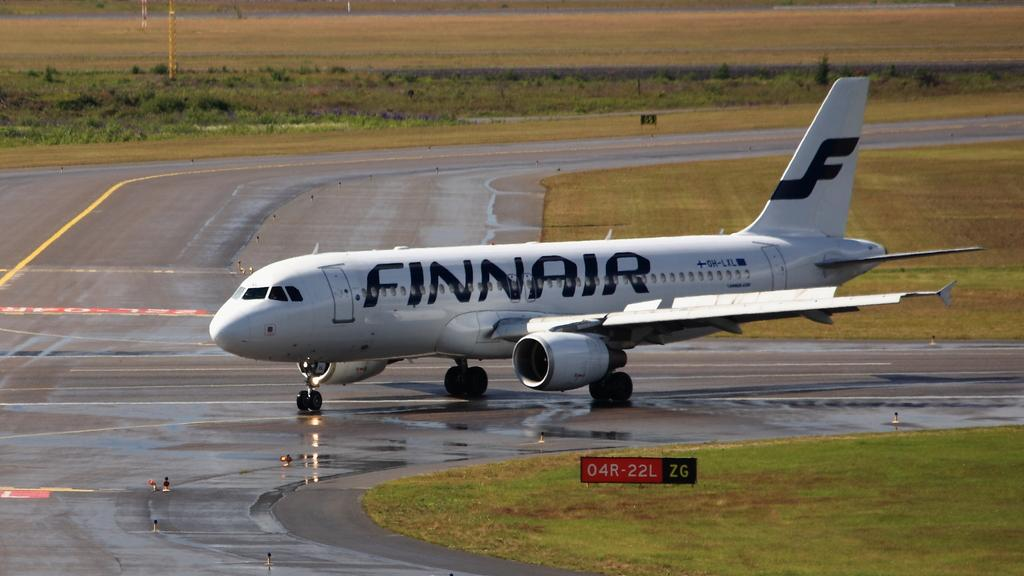<image>
Describe the image concisely. The white Finnair plane is on the tarmac. 